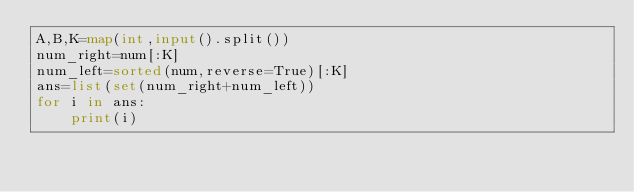<code> <loc_0><loc_0><loc_500><loc_500><_Python_>A,B,K=map(int,input().split())
num_right=num[:K]
num_left=sorted(num,reverse=True)[:K]
ans=list(set(num_right+num_left))
for i in ans:
    print(i)</code> 